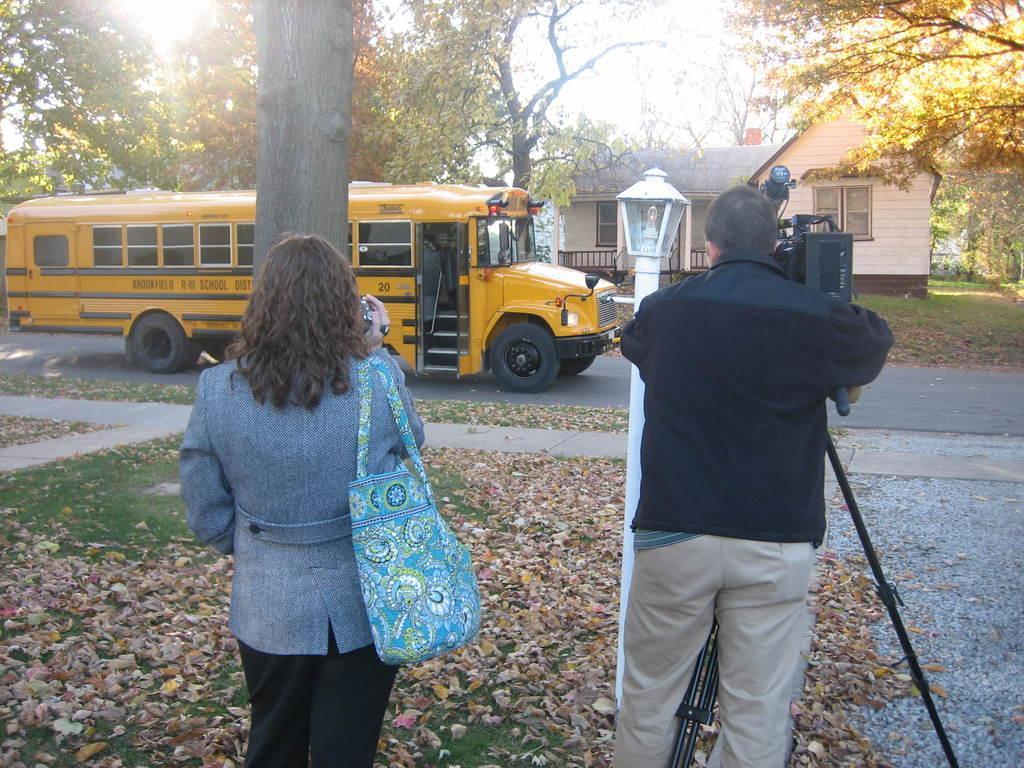Can you describe this image briefly? In the picture we can see a grass surface on it we can see dried leaves and on it we can see a man and a woman standing, man is holding camera and capturing something, the camera is on the tripod and woman is also holding a camera and she is wearing hand bag and she is capturing a bus in front of her on the road and the bus is yellow in color and behind it we can see some trees and house with railing, windows and door and behind it we can see a sky. 